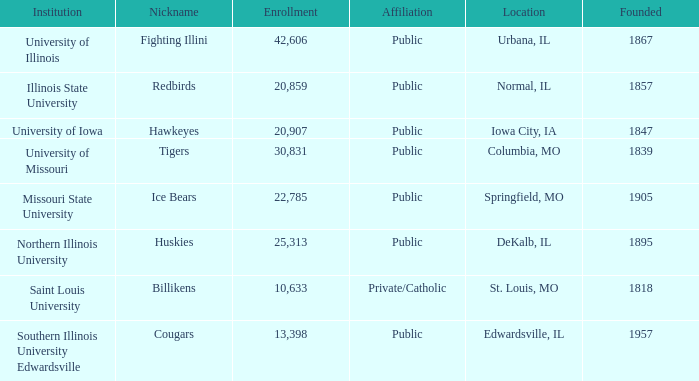Which institution is private/catholic? Saint Louis University. 